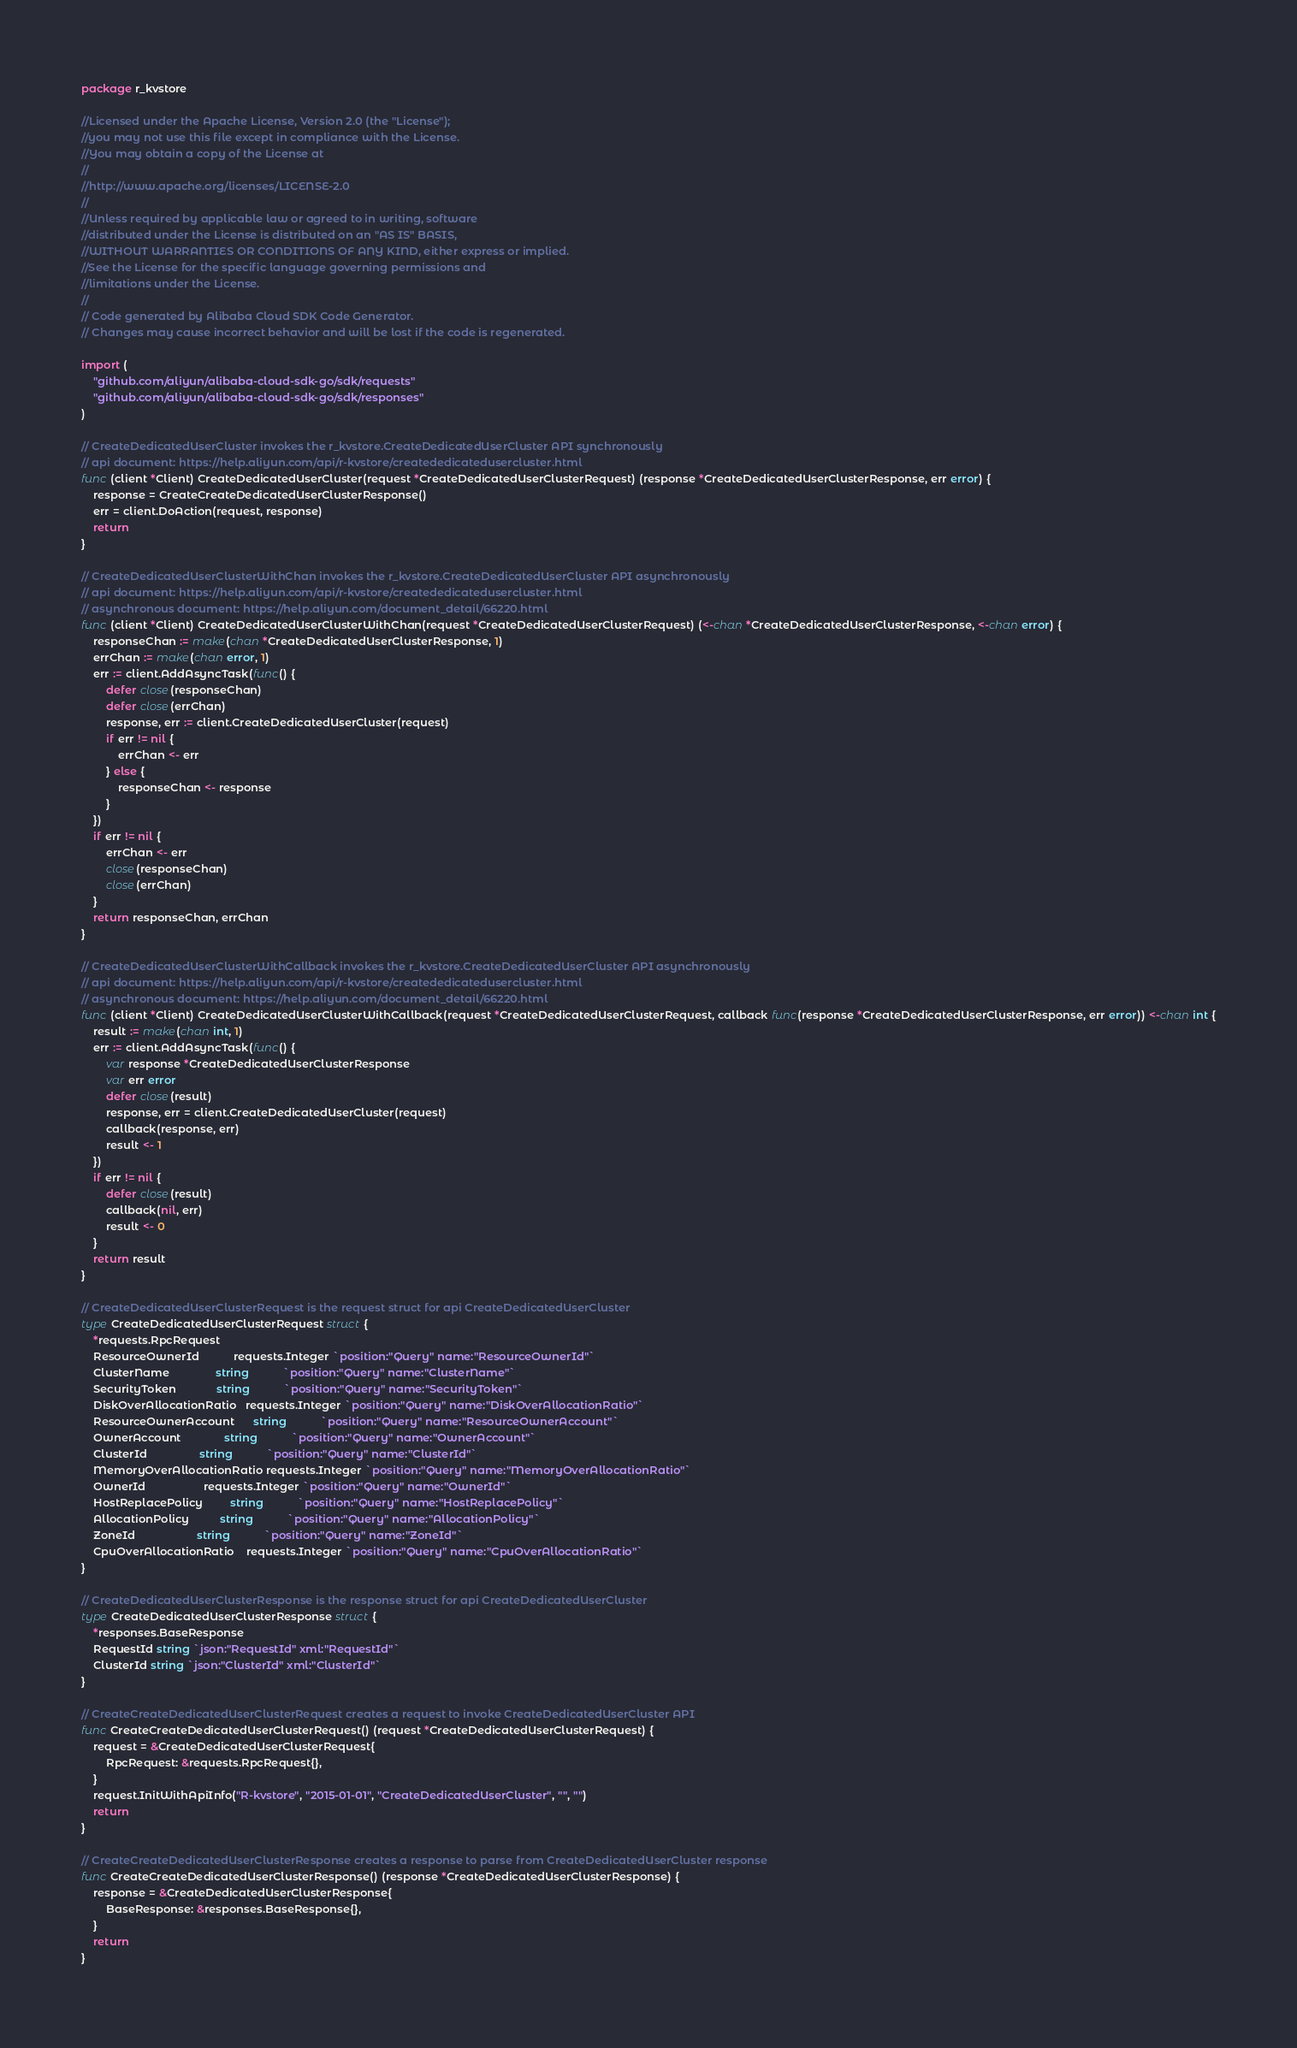Convert code to text. <code><loc_0><loc_0><loc_500><loc_500><_Go_>package r_kvstore

//Licensed under the Apache License, Version 2.0 (the "License");
//you may not use this file except in compliance with the License.
//You may obtain a copy of the License at
//
//http://www.apache.org/licenses/LICENSE-2.0
//
//Unless required by applicable law or agreed to in writing, software
//distributed under the License is distributed on an "AS IS" BASIS,
//WITHOUT WARRANTIES OR CONDITIONS OF ANY KIND, either express or implied.
//See the License for the specific language governing permissions and
//limitations under the License.
//
// Code generated by Alibaba Cloud SDK Code Generator.
// Changes may cause incorrect behavior and will be lost if the code is regenerated.

import (
	"github.com/aliyun/alibaba-cloud-sdk-go/sdk/requests"
	"github.com/aliyun/alibaba-cloud-sdk-go/sdk/responses"
)

// CreateDedicatedUserCluster invokes the r_kvstore.CreateDedicatedUserCluster API synchronously
// api document: https://help.aliyun.com/api/r-kvstore/creatededicatedusercluster.html
func (client *Client) CreateDedicatedUserCluster(request *CreateDedicatedUserClusterRequest) (response *CreateDedicatedUserClusterResponse, err error) {
	response = CreateCreateDedicatedUserClusterResponse()
	err = client.DoAction(request, response)
	return
}

// CreateDedicatedUserClusterWithChan invokes the r_kvstore.CreateDedicatedUserCluster API asynchronously
// api document: https://help.aliyun.com/api/r-kvstore/creatededicatedusercluster.html
// asynchronous document: https://help.aliyun.com/document_detail/66220.html
func (client *Client) CreateDedicatedUserClusterWithChan(request *CreateDedicatedUserClusterRequest) (<-chan *CreateDedicatedUserClusterResponse, <-chan error) {
	responseChan := make(chan *CreateDedicatedUserClusterResponse, 1)
	errChan := make(chan error, 1)
	err := client.AddAsyncTask(func() {
		defer close(responseChan)
		defer close(errChan)
		response, err := client.CreateDedicatedUserCluster(request)
		if err != nil {
			errChan <- err
		} else {
			responseChan <- response
		}
	})
	if err != nil {
		errChan <- err
		close(responseChan)
		close(errChan)
	}
	return responseChan, errChan
}

// CreateDedicatedUserClusterWithCallback invokes the r_kvstore.CreateDedicatedUserCluster API asynchronously
// api document: https://help.aliyun.com/api/r-kvstore/creatededicatedusercluster.html
// asynchronous document: https://help.aliyun.com/document_detail/66220.html
func (client *Client) CreateDedicatedUserClusterWithCallback(request *CreateDedicatedUserClusterRequest, callback func(response *CreateDedicatedUserClusterResponse, err error)) <-chan int {
	result := make(chan int, 1)
	err := client.AddAsyncTask(func() {
		var response *CreateDedicatedUserClusterResponse
		var err error
		defer close(result)
		response, err = client.CreateDedicatedUserCluster(request)
		callback(response, err)
		result <- 1
	})
	if err != nil {
		defer close(result)
		callback(nil, err)
		result <- 0
	}
	return result
}

// CreateDedicatedUserClusterRequest is the request struct for api CreateDedicatedUserCluster
type CreateDedicatedUserClusterRequest struct {
	*requests.RpcRequest
	ResourceOwnerId           requests.Integer `position:"Query" name:"ResourceOwnerId"`
	ClusterName               string           `position:"Query" name:"ClusterName"`
	SecurityToken             string           `position:"Query" name:"SecurityToken"`
	DiskOverAllocationRatio   requests.Integer `position:"Query" name:"DiskOverAllocationRatio"`
	ResourceOwnerAccount      string           `position:"Query" name:"ResourceOwnerAccount"`
	OwnerAccount              string           `position:"Query" name:"OwnerAccount"`
	ClusterId                 string           `position:"Query" name:"ClusterId"`
	MemoryOverAllocationRatio requests.Integer `position:"Query" name:"MemoryOverAllocationRatio"`
	OwnerId                   requests.Integer `position:"Query" name:"OwnerId"`
	HostReplacePolicy         string           `position:"Query" name:"HostReplacePolicy"`
	AllocationPolicy          string           `position:"Query" name:"AllocationPolicy"`
	ZoneId                    string           `position:"Query" name:"ZoneId"`
	CpuOverAllocationRatio    requests.Integer `position:"Query" name:"CpuOverAllocationRatio"`
}

// CreateDedicatedUserClusterResponse is the response struct for api CreateDedicatedUserCluster
type CreateDedicatedUserClusterResponse struct {
	*responses.BaseResponse
	RequestId string `json:"RequestId" xml:"RequestId"`
	ClusterId string `json:"ClusterId" xml:"ClusterId"`
}

// CreateCreateDedicatedUserClusterRequest creates a request to invoke CreateDedicatedUserCluster API
func CreateCreateDedicatedUserClusterRequest() (request *CreateDedicatedUserClusterRequest) {
	request = &CreateDedicatedUserClusterRequest{
		RpcRequest: &requests.RpcRequest{},
	}
	request.InitWithApiInfo("R-kvstore", "2015-01-01", "CreateDedicatedUserCluster", "", "")
	return
}

// CreateCreateDedicatedUserClusterResponse creates a response to parse from CreateDedicatedUserCluster response
func CreateCreateDedicatedUserClusterResponse() (response *CreateDedicatedUserClusterResponse) {
	response = &CreateDedicatedUserClusterResponse{
		BaseResponse: &responses.BaseResponse{},
	}
	return
}
</code> 